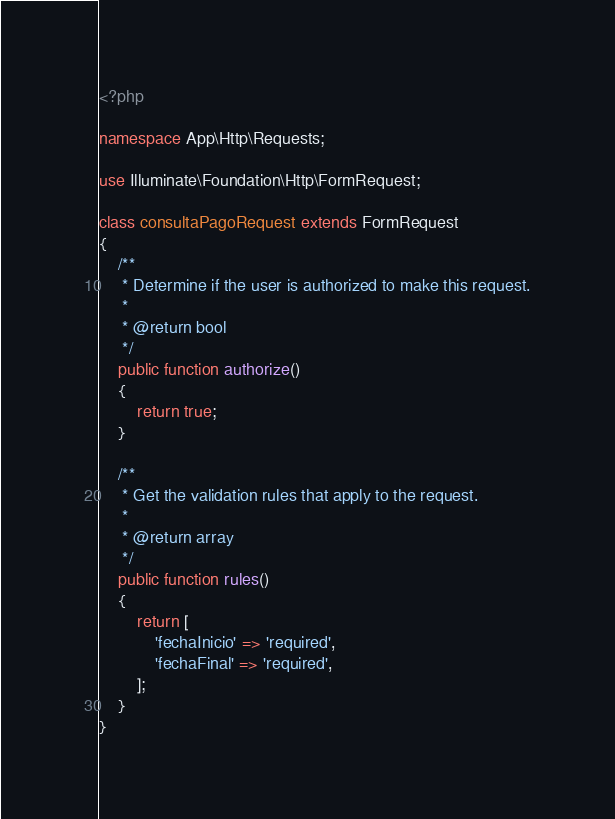Convert code to text. <code><loc_0><loc_0><loc_500><loc_500><_PHP_><?php

namespace App\Http\Requests;

use Illuminate\Foundation\Http\FormRequest;

class consultaPagoRequest extends FormRequest
{
    /**
     * Determine if the user is authorized to make this request.
     *
     * @return bool
     */
    public function authorize()
    {
        return true;
    }

    /**
     * Get the validation rules that apply to the request.
     *
     * @return array
     */
    public function rules()
    {
        return [
            'fechaInicio' => 'required',
            'fechaFinal' => 'required',
        ];
    }
}
</code> 